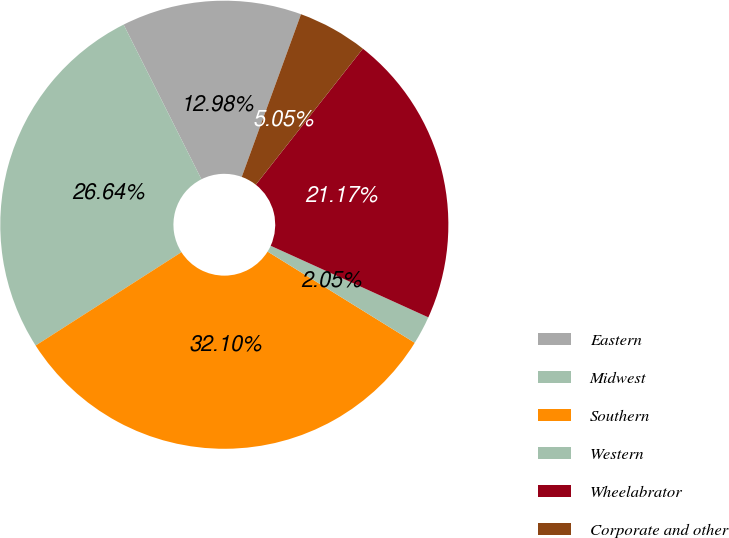<chart> <loc_0><loc_0><loc_500><loc_500><pie_chart><fcel>Eastern<fcel>Midwest<fcel>Southern<fcel>Western<fcel>Wheelabrator<fcel>Corporate and other<nl><fcel>12.98%<fcel>26.64%<fcel>32.1%<fcel>2.05%<fcel>21.17%<fcel>5.05%<nl></chart> 